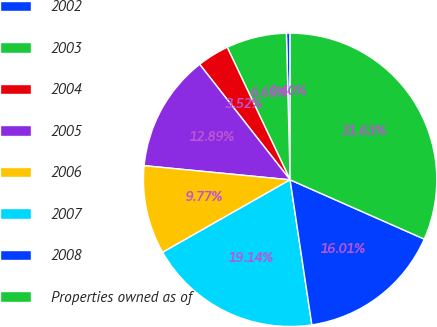Convert chart. <chart><loc_0><loc_0><loc_500><loc_500><pie_chart><fcel>2002<fcel>2003<fcel>2004<fcel>2005<fcel>2006<fcel>2007<fcel>2008<fcel>Properties owned as of<nl><fcel>0.4%<fcel>6.65%<fcel>3.52%<fcel>12.89%<fcel>9.77%<fcel>19.14%<fcel>16.01%<fcel>31.63%<nl></chart> 